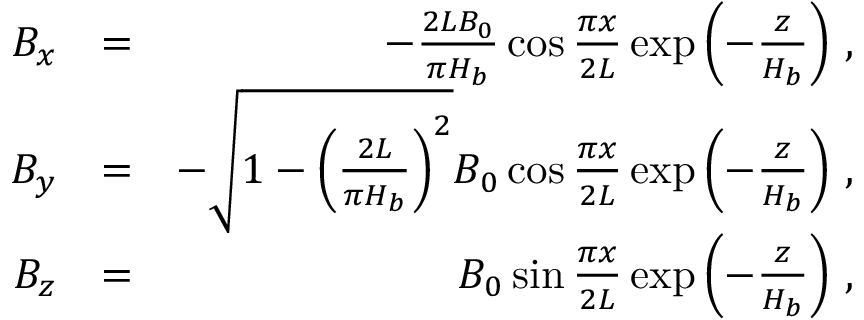<formula> <loc_0><loc_0><loc_500><loc_500>\begin{array} { r l r } { B _ { x } } & { = } & { - \frac { 2 L B _ { 0 } } { \pi H _ { b } } \cos { \frac { \pi x } { 2 L } } \exp \left ( { - \frac { z } { H _ { b } } } \right ) \, , } \\ { B _ { y } } & { = } & { - \sqrt { 1 - \left ( \frac { 2 L } { \pi H _ { b } } \right ) ^ { 2 } } B _ { 0 } \cos { \frac { \pi x } { 2 L } } \exp \left ( { - \frac { z } { H _ { b } } } \right ) \, , } \\ { B _ { z } } & { = } & { B _ { 0 } \sin { \frac { \pi x } { 2 L } } \exp \left ( { - \frac { z } { H _ { b } } } \right ) \, , } \end{array}</formula> 